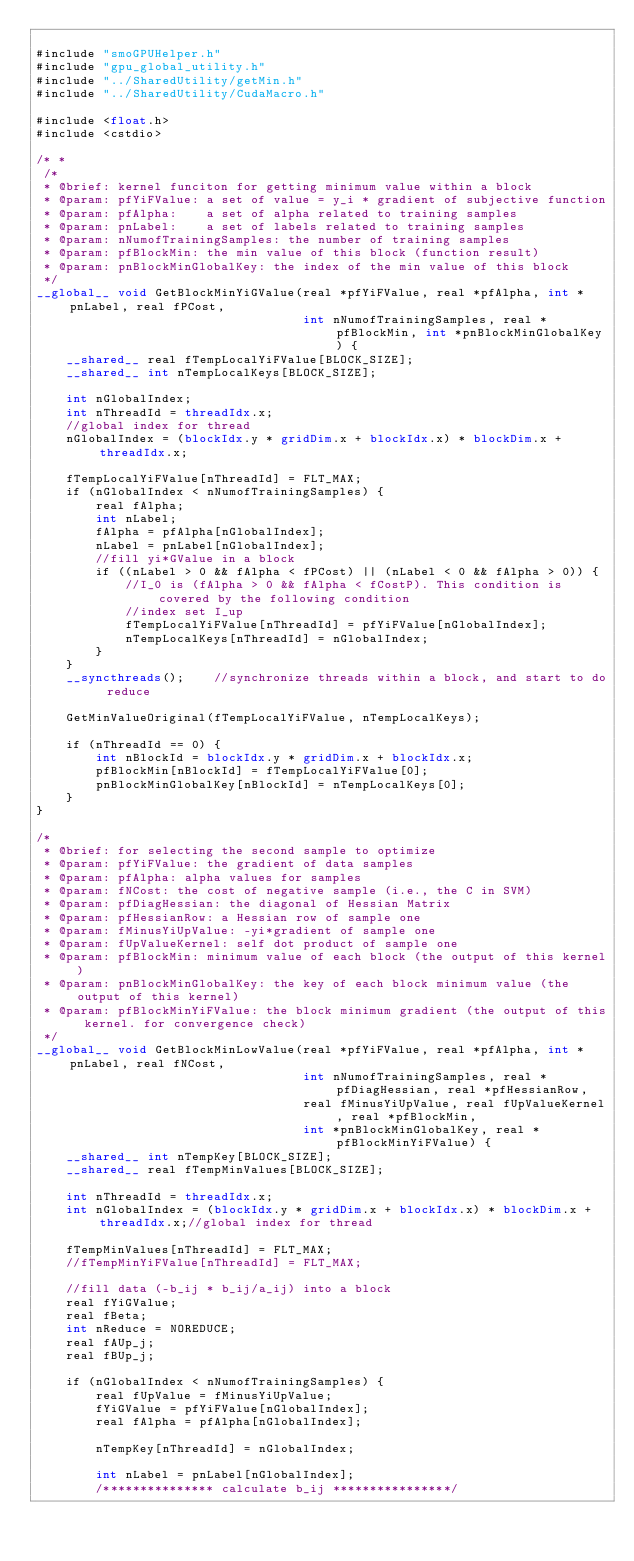<code> <loc_0><loc_0><loc_500><loc_500><_Cuda_>
#include "smoGPUHelper.h"
#include "gpu_global_utility.h"
#include "../SharedUtility/getMin.h"
#include "../SharedUtility/CudaMacro.h"

#include <float.h>
#include <cstdio>

/* *
 /*
 * @brief: kernel funciton for getting minimum value within a block
 * @param: pfYiFValue: a set of value = y_i * gradient of subjective function
 * @param: pfAlpha:	   a set of alpha related to training samples
 * @param: pnLabel:	   a set of labels related to training samples
 * @param: nNumofTrainingSamples: the number of training samples
 * @param: pfBlockMin: the min value of this block (function result)
 * @param: pnBlockMinGlobalKey: the index of the min value of this block
 */
__global__ void GetBlockMinYiGValue(real *pfYiFValue, real *pfAlpha, int *pnLabel, real fPCost,
                                    int nNumofTrainingSamples, real *pfBlockMin, int *pnBlockMinGlobalKey) {
    __shared__ real fTempLocalYiFValue[BLOCK_SIZE];
    __shared__ int nTempLocalKeys[BLOCK_SIZE];

    int nGlobalIndex;
    int nThreadId = threadIdx.x;
    //global index for thread
    nGlobalIndex = (blockIdx.y * gridDim.x + blockIdx.x) * blockDim.x + threadIdx.x;

    fTempLocalYiFValue[nThreadId] = FLT_MAX;
    if (nGlobalIndex < nNumofTrainingSamples) {
        real fAlpha;
        int nLabel;
        fAlpha = pfAlpha[nGlobalIndex];
        nLabel = pnLabel[nGlobalIndex];
        //fill yi*GValue in a block
        if ((nLabel > 0 && fAlpha < fPCost) || (nLabel < 0 && fAlpha > 0)) {
            //I_0 is (fAlpha > 0 && fAlpha < fCostP). This condition is covered by the following condition
            //index set I_up
            fTempLocalYiFValue[nThreadId] = pfYiFValue[nGlobalIndex];
            nTempLocalKeys[nThreadId] = nGlobalIndex;
        }
    }
    __syncthreads();    //synchronize threads within a block, and start to do reduce

    GetMinValueOriginal(fTempLocalYiFValue, nTempLocalKeys);

    if (nThreadId == 0) {
        int nBlockId = blockIdx.y * gridDim.x + blockIdx.x;
        pfBlockMin[nBlockId] = fTempLocalYiFValue[0];
        pnBlockMinGlobalKey[nBlockId] = nTempLocalKeys[0];
    }
}

/*
 * @brief: for selecting the second sample to optimize
 * @param: pfYiFValue: the gradient of data samples
 * @param: pfAlpha: alpha values for samples
 * @param: fNCost: the cost of negative sample (i.e., the C in SVM)
 * @param: pfDiagHessian: the diagonal of Hessian Matrix
 * @param: pfHessianRow: a Hessian row of sample one
 * @param: fMinusYiUpValue: -yi*gradient of sample one
 * @param: fUpValueKernel: self dot product of sample one
 * @param: pfBlockMin: minimum value of each block (the output of this kernel)
 * @param: pnBlockMinGlobalKey: the key of each block minimum value (the output of this kernel)
 * @param: pfBlockMinYiFValue: the block minimum gradient (the output of this kernel. for convergence check)
 */
__global__ void GetBlockMinLowValue(real *pfYiFValue, real *pfAlpha, int *pnLabel, real fNCost,
                                    int nNumofTrainingSamples, real *pfDiagHessian, real *pfHessianRow,
                                    real fMinusYiUpValue, real fUpValueKernel, real *pfBlockMin,
                                    int *pnBlockMinGlobalKey, real *pfBlockMinYiFValue) {
    __shared__ int nTempKey[BLOCK_SIZE];
    __shared__ real fTempMinValues[BLOCK_SIZE];

    int nThreadId = threadIdx.x;
    int nGlobalIndex = (blockIdx.y * gridDim.x + blockIdx.x) * blockDim.x + threadIdx.x;//global index for thread

    fTempMinValues[nThreadId] = FLT_MAX;
    //fTempMinYiFValue[nThreadId] = FLT_MAX;

    //fill data (-b_ij * b_ij/a_ij) into a block
    real fYiGValue;
    real fBeta;
    int nReduce = NOREDUCE;
    real fAUp_j;
    real fBUp_j;

    if (nGlobalIndex < nNumofTrainingSamples) {
        real fUpValue = fMinusYiUpValue;
        fYiGValue = pfYiFValue[nGlobalIndex];
        real fAlpha = pfAlpha[nGlobalIndex];

        nTempKey[nThreadId] = nGlobalIndex;

        int nLabel = pnLabel[nGlobalIndex];
        /*************** calculate b_ij ****************/</code> 